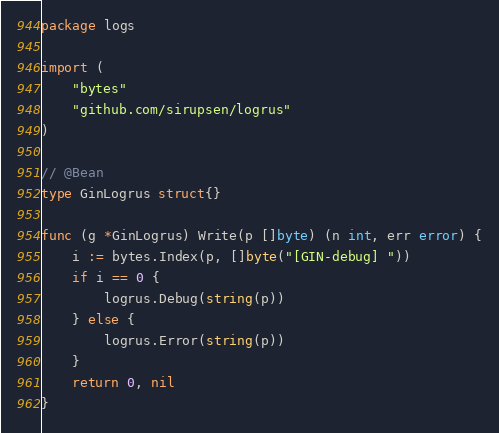Convert code to text. <code><loc_0><loc_0><loc_500><loc_500><_Go_>package logs

import (
	"bytes"
	"github.com/sirupsen/logrus"
)

// @Bean
type GinLogrus struct{}

func (g *GinLogrus) Write(p []byte) (n int, err error) {
	i := bytes.Index(p, []byte("[GIN-debug] "))
	if i == 0 {
		logrus.Debug(string(p))
	} else {
		logrus.Error(string(p))
	}
	return 0, nil
}
</code> 